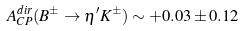<formula> <loc_0><loc_0><loc_500><loc_500>A _ { C P } ^ { d i r } ( B ^ { \pm } \to \eta ^ { \prime } K ^ { \pm } ) \sim + 0 . 0 3 \pm 0 . 1 2</formula> 